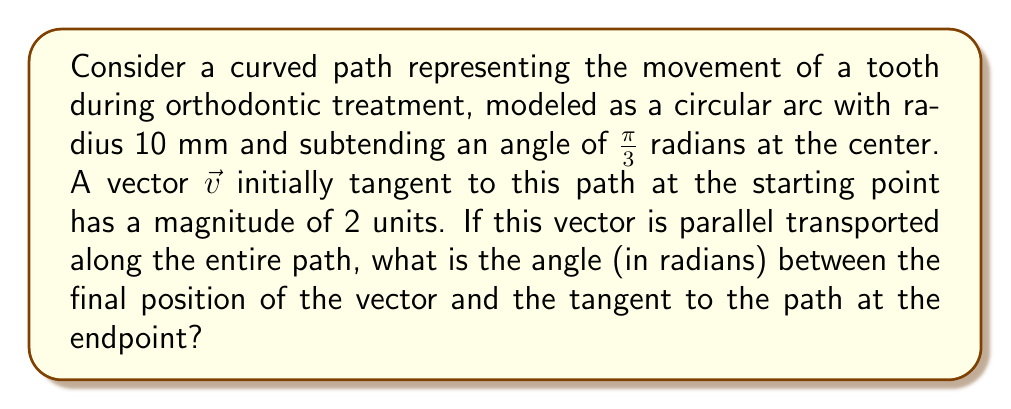Give your solution to this math problem. Let's approach this step-by-step:

1) In non-Euclidean geometry, parallel transport along a curved path results in a rotation of the vector relative to the path's tangent.

2) For a circular arc, the angle of rotation is equal to the angle subtended by the arc at the center. This is because the tangent to a circle rotates at the same rate as the radius vector.

3) In this case, the arc subtends an angle of $\frac{\pi}{3}$ radians at the center.

4) The initial vector $\vec{v}$ is tangent to the path at the starting point, so the initial angle between $\vec{v}$ and the path tangent is 0.

5) After parallel transport along the entire path, $\vec{v}$ will have rotated by $\frac{\pi}{3}$ radians relative to the path tangent.

6) Therefore, at the endpoint, the angle between the transported vector $\vec{v}$ and the path tangent will be $\frac{\pi}{3}$ radians.

This result is independent of the magnitude of $\vec{v}$ and the radius of the circular arc, as long as the subtended angle remains $\frac{\pi}{3}$.

[asy]
import geometry;

size(200);
pair O = (0,0);
real r = 5;
path c = arc(O, r, 0, 60);
draw(c, blue);

pair A = point(c, 0);
pair B = point(c, 1);

draw(O--A, dashed);
draw(O--B, dashed);

vector v1 = (2,0);
vector v2 = rotate(60)*v1;

draw(A--A+v1, arrow=Arrow(TeXHead));
draw(B--B+v2, arrow=Arrow(TeXHead));

label("O", O, SW);
label("A", A, S);
label("B", B, NE);
label("$\vec{v}$", A+v1/2, N);
label("$\vec{v'}$", B+v2/2, NW);

draw(arc(B, 0.5, 270, 330), arrow=Arrow(TeXHead));
label("$\frac{\pi}{3}$", B+(0.7,0.2), NE);
[/asy]
Answer: $\frac{\pi}{3}$ radians 